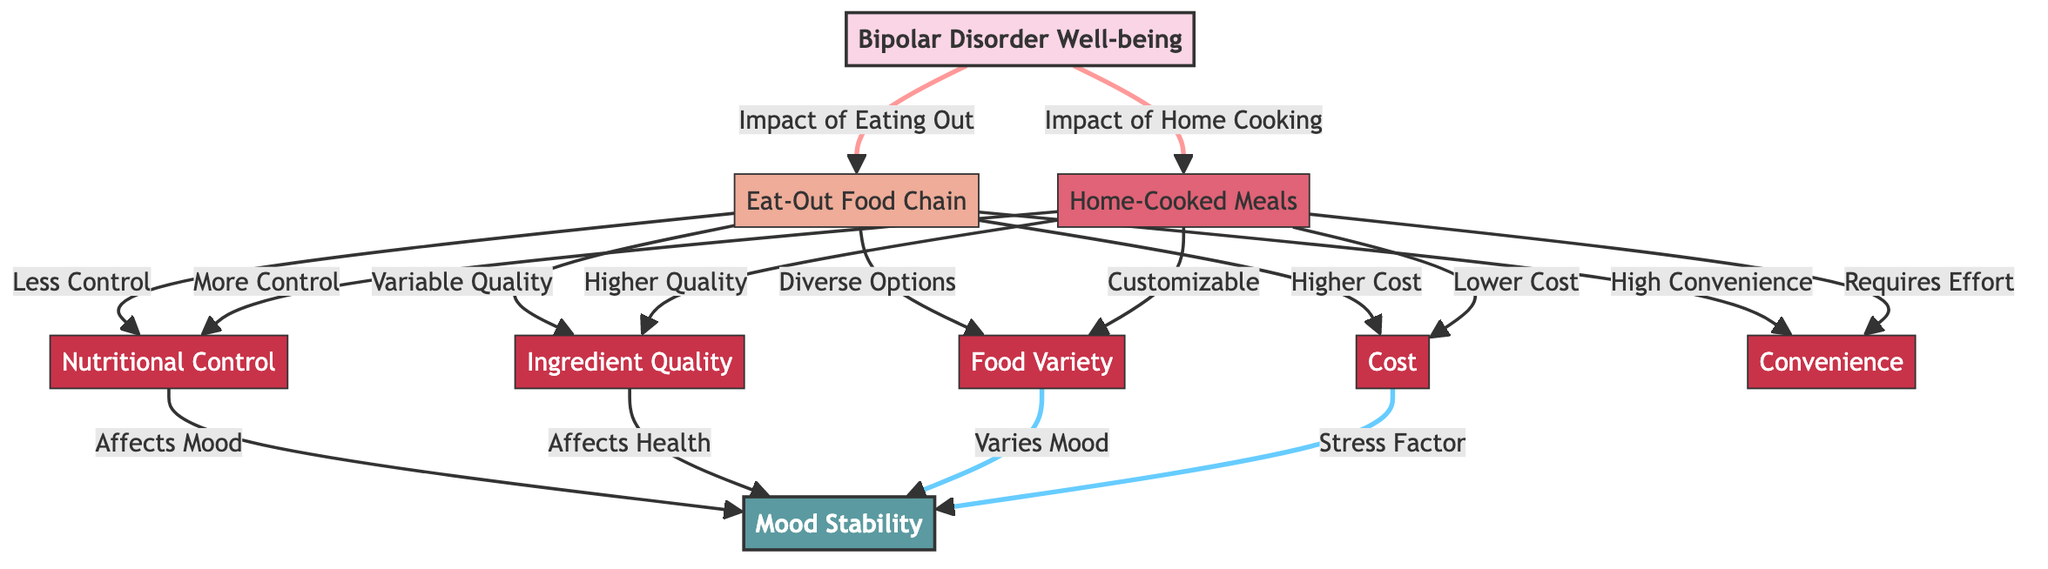What is the total number of nodes in the diagram? The diagram consists of 9 nodes in total, including main nodes and factor nodes.
Answer: 9 Which meal option has more control over nutritional factors? The arrows in the diagram show that home-cooked meals lead to more control over nutritional factors compared to eat-out options.
Answer: Home-Cooked Meals What type of meal option is associated with higher costs? The diagram indicates that the eat-out food chain is associated with higher costs when compared to home-cooked meals.
Answer: Eat-Out Food Chain What is the impact of ingredient quality on mood stability? According to the diagram, ingredient quality affects health, which in turn influences mood stability.
Answer: Affects Health How does food variety influence mood stability? The diagram shows that food variety varies mood, indicating a direct relationship with mood stability.
Answer: Varies Mood What is one characteristic of home-cooked meals related to food variety? The diagram suggests that home-cooked meals are customizable, which enhances food variety compared to eating out.
Answer: Customizable Which option shows reliance on convenience? The flow in the diagram shows that the eat-out food chain is connected to high convenience in meal preparation.
Answer: Eat-Out Food Chain What factor leads to mood instability from eating out? The diagram links the concept of variable quality in ingredients to potential variations in mood stability.
Answer: Variable Quality Which meal option generally requires more effort to prepare? The relationships in the diagram indicate that home-cooked meals require effort compared to the convenience of eating out.
Answer: Home-Cooked Meals 